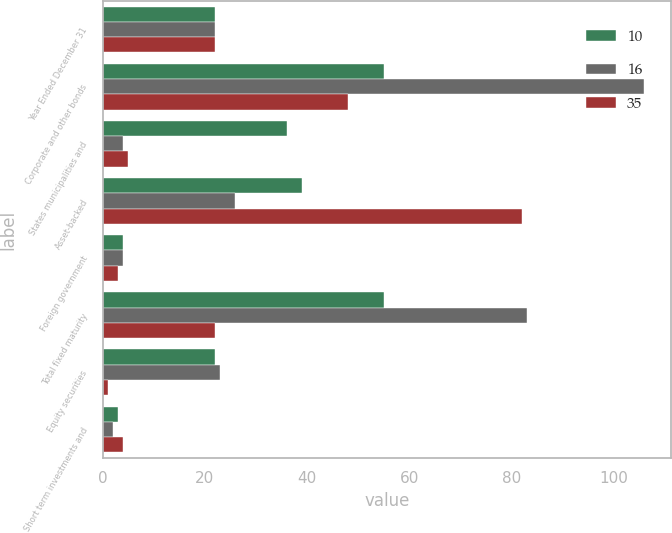<chart> <loc_0><loc_0><loc_500><loc_500><stacked_bar_chart><ecel><fcel>Year Ended December 31<fcel>Corporate and other bonds<fcel>States municipalities and<fcel>Asset-backed<fcel>Foreign government<fcel>Total fixed maturity<fcel>Equity securities<fcel>Short term investments and<nl><fcel>10<fcel>22<fcel>55<fcel>36<fcel>39<fcel>4<fcel>55<fcel>22<fcel>3<nl><fcel>16<fcel>22<fcel>106<fcel>4<fcel>26<fcel>4<fcel>83<fcel>23<fcel>2<nl><fcel>35<fcel>22<fcel>48<fcel>5<fcel>82<fcel>3<fcel>22<fcel>1<fcel>4<nl></chart> 